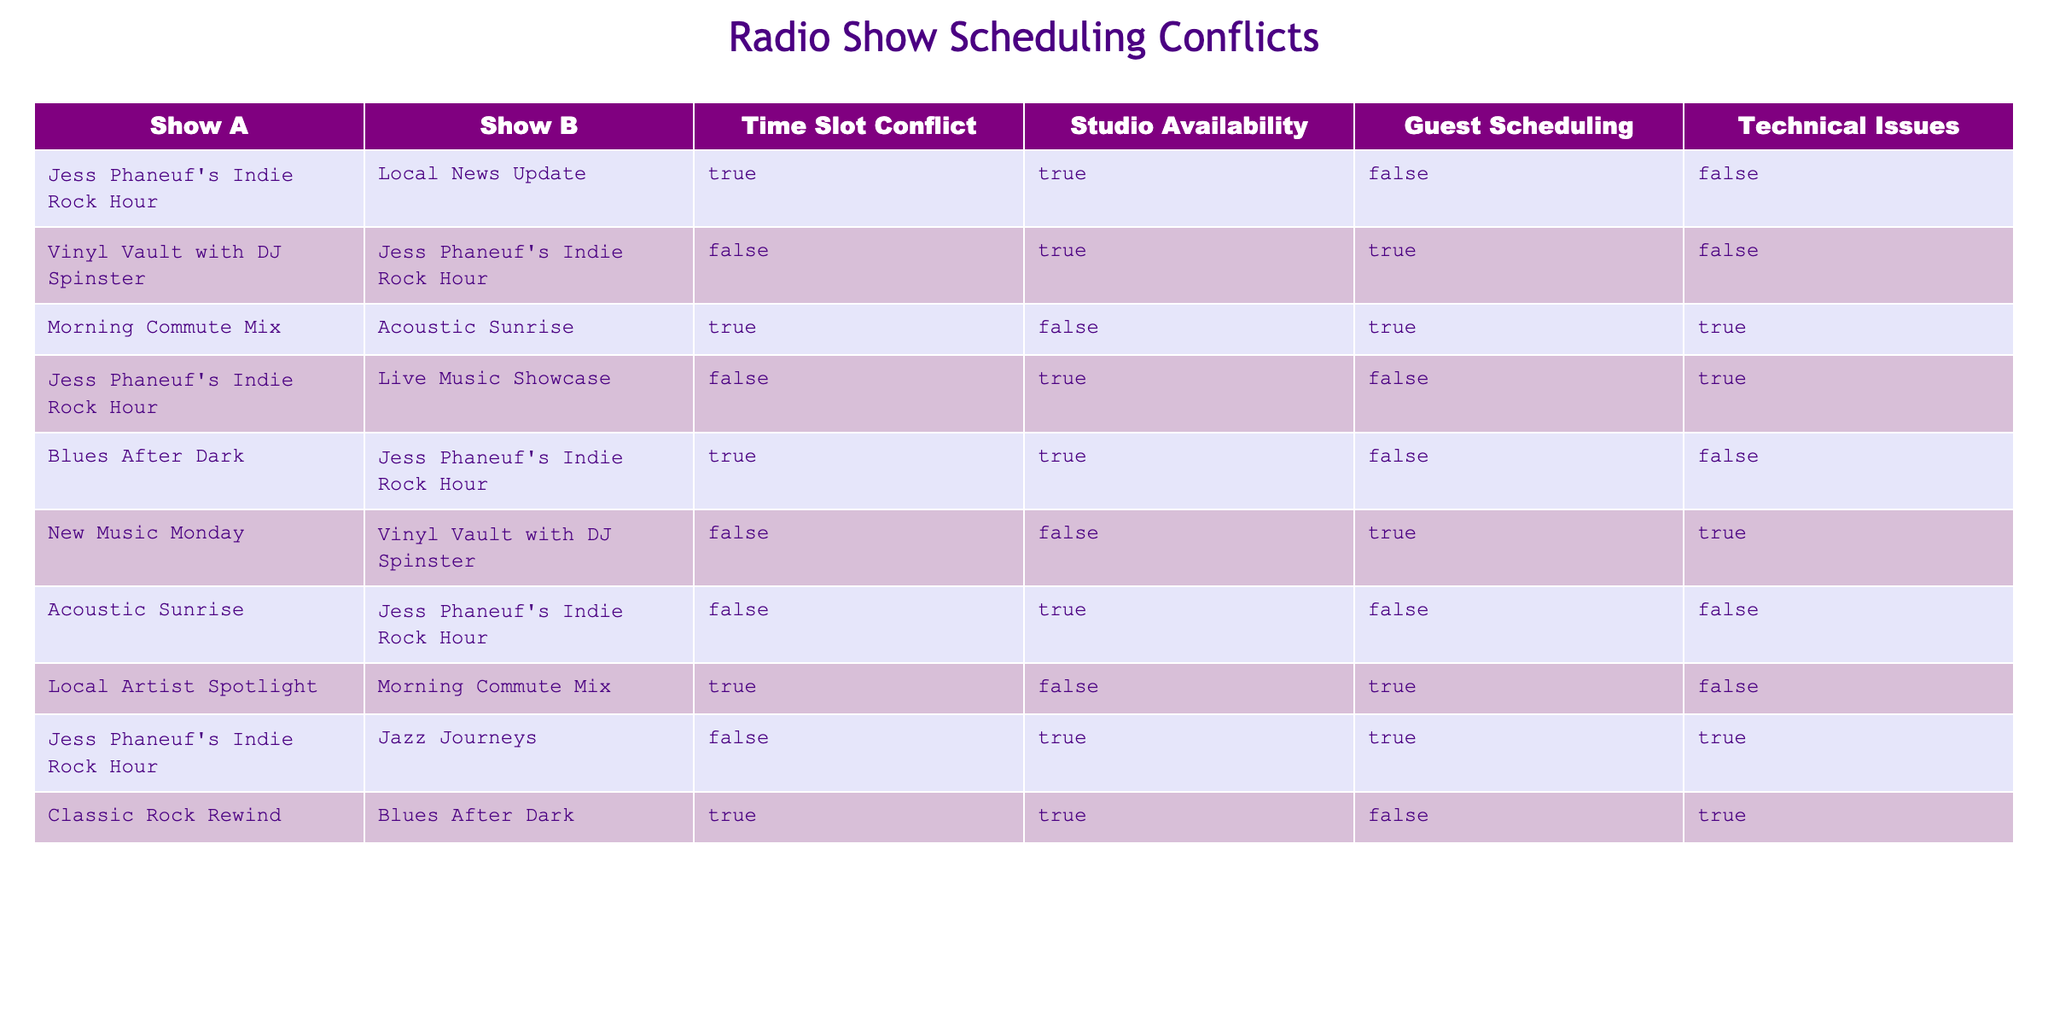What shows have a time slot conflict with Jess Phaneuf's Indie Rock Hour? The table indicates that "Local News Update," "Blues After Dark," and "Acoustic Sunrise" have a time slot conflict with "Jess Phaneuf's Indie Rock Hour." Therefore, these shows must be checked from the table under the "Time Slot Conflict" column where it matches TRUE and the corresponding show in the first column is "Jess Phaneuf's Indie Rock Hour."
Answer: Local News Update, Blues After Dark, Acoustic Sunrise Is there studio availability for the show "Morning Commute Mix"? Looking at the row for "Morning Commute Mix," the "Studio Availability" column shows FALSE. Thus, there is no studio availability for this show as indicated in the table.
Answer: No How many shows have guest scheduling issues? To find the shows with guest scheduling issues, look at the "Guest Scheduling" column and count the rows where the value is TRUE. Summing them gives us three shows: "Vinyl Vault with DJ Spinster," "Morning Commute Mix," and "New Music Monday." Therefore, the total is 3.
Answer: 3 Does "Acoustic Sunrise" face any technical issues? Checking the "Technical Issues" column for "Acoustic Sunrise," the table indicates FALSE. Therefore, there are no technical issues related to this show.
Answer: No Which show has conflicts paired with Jess Phaneuf's Indie Rock Hour besides "Blues After Dark"? The only show that has conflicts with "Jess Phaneuf's Indie Rock Hour" as per the table, apart from "Blues After Dark," is "Local News Update." The logical reasoning involves scanning the "Show A" column for "Jess Phaneuf's Indie Rock Hour," checking the corresponding entries under "Show B," and identifying the related conflicts.
Answer: Local News Update 